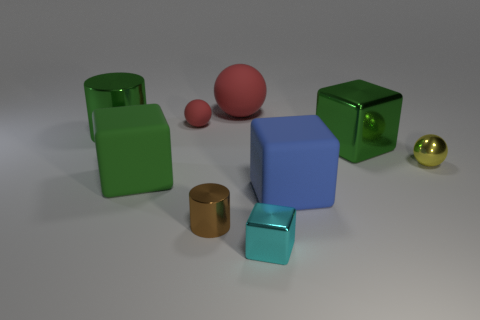Subtract all cylinders. How many objects are left? 7 Subtract 0 purple cylinders. How many objects are left? 9 Subtract all large shiny things. Subtract all large green cylinders. How many objects are left? 6 Add 1 small shiny balls. How many small shiny balls are left? 2 Add 5 green shiny cylinders. How many green shiny cylinders exist? 6 